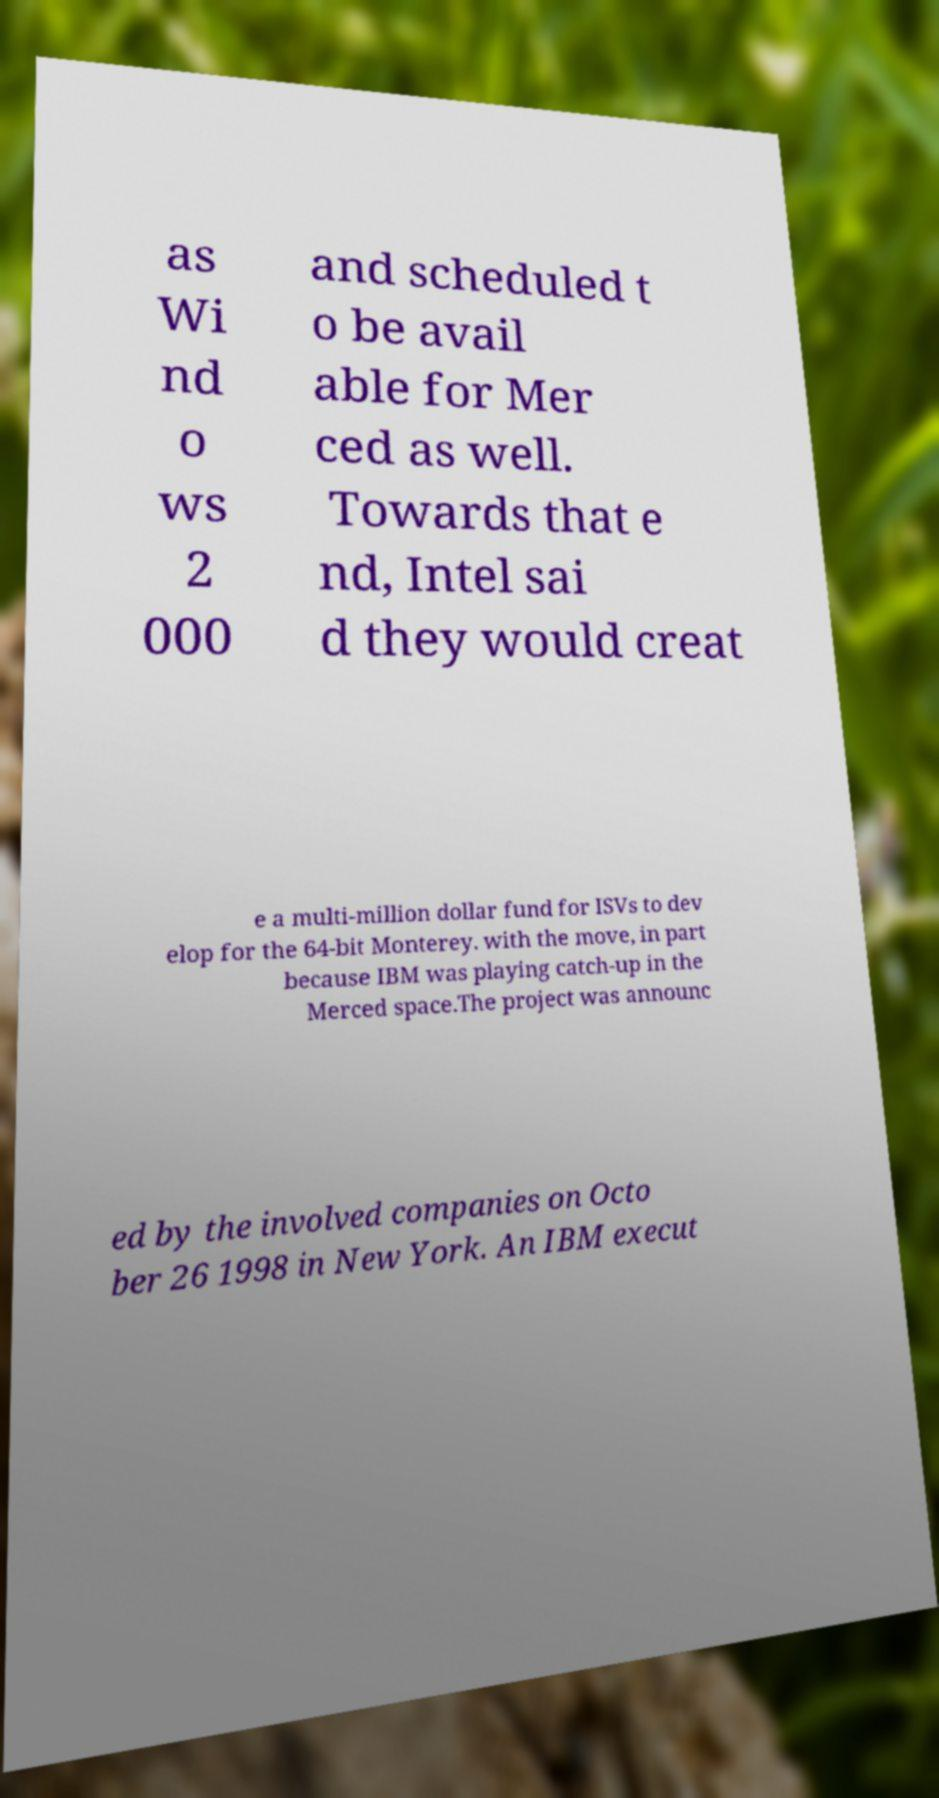What messages or text are displayed in this image? I need them in a readable, typed format. as Wi nd o ws 2 000 and scheduled t o be avail able for Mer ced as well. Towards that e nd, Intel sai d they would creat e a multi-million dollar fund for ISVs to dev elop for the 64-bit Monterey. with the move, in part because IBM was playing catch-up in the Merced space.The project was announc ed by the involved companies on Octo ber 26 1998 in New York. An IBM execut 